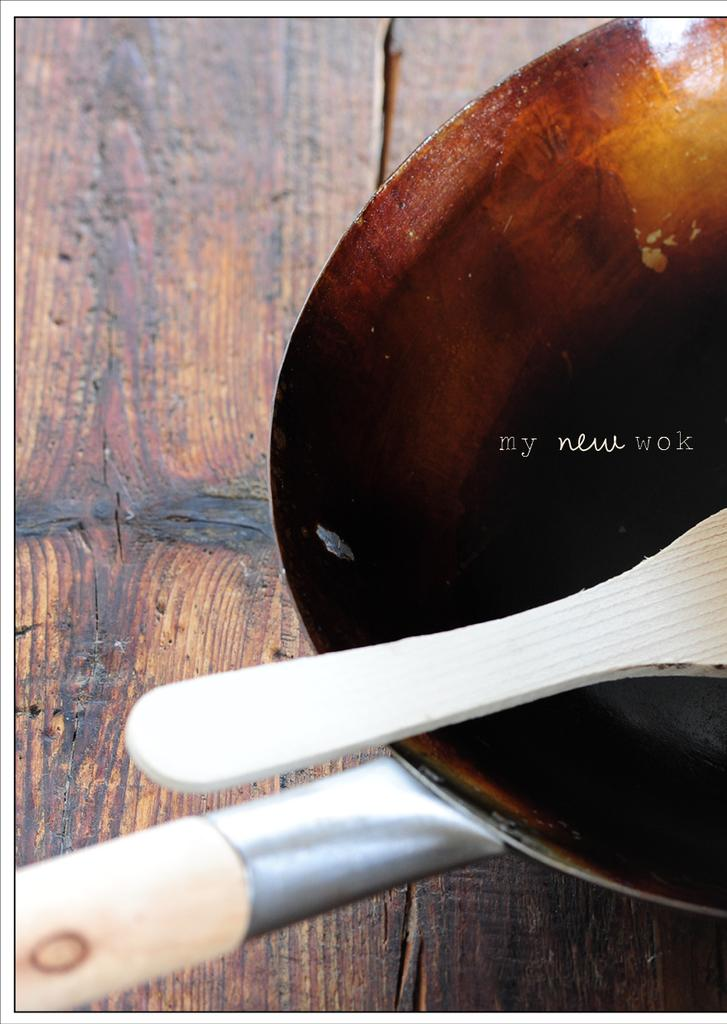What is the main object in the foreground of the image? There is a pan in the foreground of the image. What is placed on the pan? A wooden spatula is placed on the pan. On what surface is the wooden spatula resting? The wooden spatula is on a wooden surface. Who is the creator of the wooden spatula in the image? There is no information about the creator of the wooden spatula in the image. Can you hear any sounds coming from the wooden spatula in the image? The image is silent, and there are no sounds associated with the wooden spatula. 